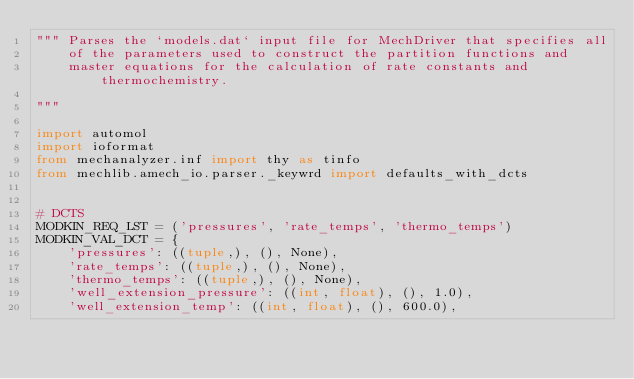<code> <loc_0><loc_0><loc_500><loc_500><_Python_>""" Parses the `models.dat` input file for MechDriver that specifies all
    of the parameters used to construct the partition functions and
    master equations for the calculation of rate constants and thermochemistry.

"""

import automol
import ioformat
from mechanalyzer.inf import thy as tinfo
from mechlib.amech_io.parser._keywrd import defaults_with_dcts


# DCTS
MODKIN_REQ_LST = ('pressures', 'rate_temps', 'thermo_temps')
MODKIN_VAL_DCT = {
    'pressures': ((tuple,), (), None),
    'rate_temps': ((tuple,), (), None),
    'thermo_temps': ((tuple,), (), None),
    'well_extension_pressure': ((int, float), (), 1.0),
    'well_extension_temp': ((int, float), (), 600.0),</code> 